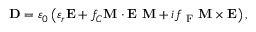Convert formula to latex. <formula><loc_0><loc_0><loc_500><loc_500>D = \varepsilon _ { 0 } \left ( \varepsilon _ { r } E + f _ { C } M \cdot E \ M + i f _ { F } M \times E \right ) ,</formula> 